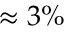<formula> <loc_0><loc_0><loc_500><loc_500>\approx 3 \%</formula> 